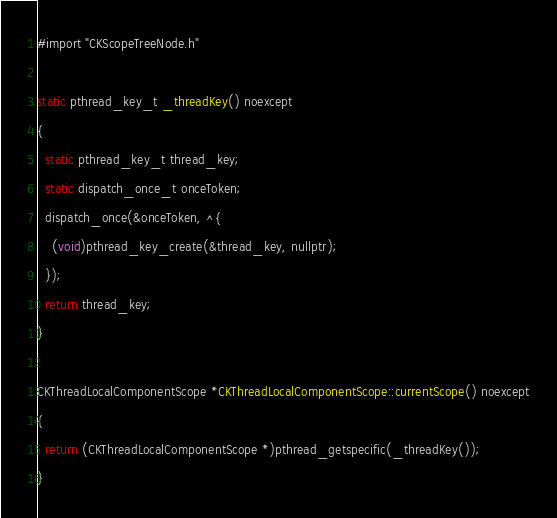Convert code to text. <code><loc_0><loc_0><loc_500><loc_500><_ObjectiveC_>#import "CKScopeTreeNode.h"

static pthread_key_t _threadKey() noexcept
{
  static pthread_key_t thread_key;
  static dispatch_once_t onceToken;
  dispatch_once(&onceToken, ^{
    (void)pthread_key_create(&thread_key, nullptr);
  });
  return thread_key;
}

CKThreadLocalComponentScope *CKThreadLocalComponentScope::currentScope() noexcept
{
  return (CKThreadLocalComponentScope *)pthread_getspecific(_threadKey());
}
</code> 